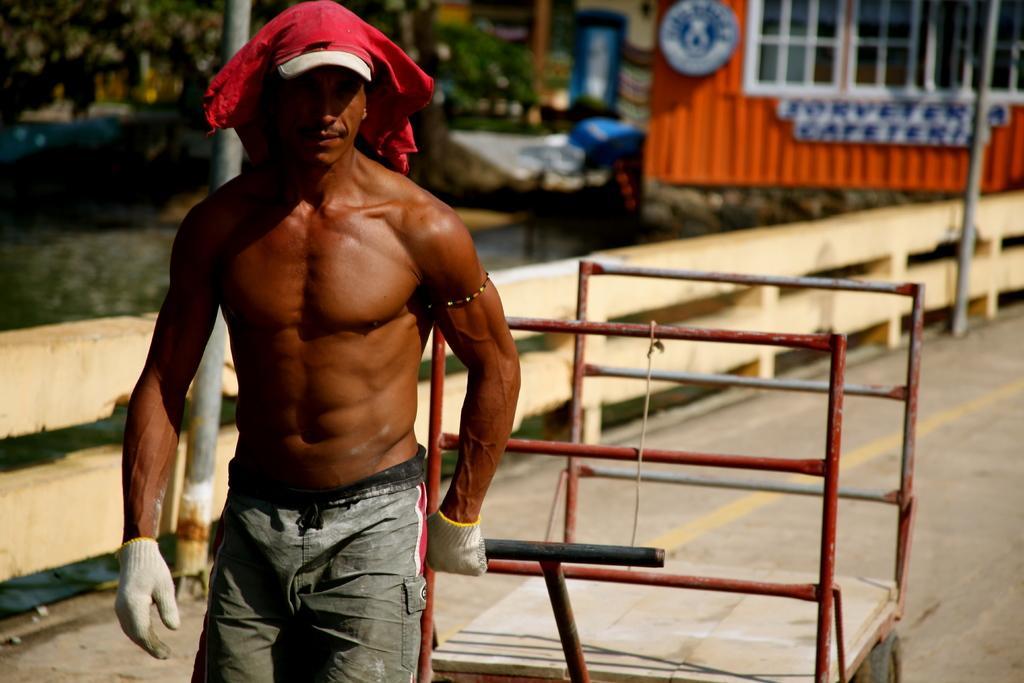Describe this image in one or two sentences. This image is taken outdoors. In the background there are a few trees and there are two poles and there is a fence. At the top right of the image there is a cabin and there is a board with a text on it and there is a pole. In the middle of the image a man is walking on the road and he is pulling a trolley on the road. 